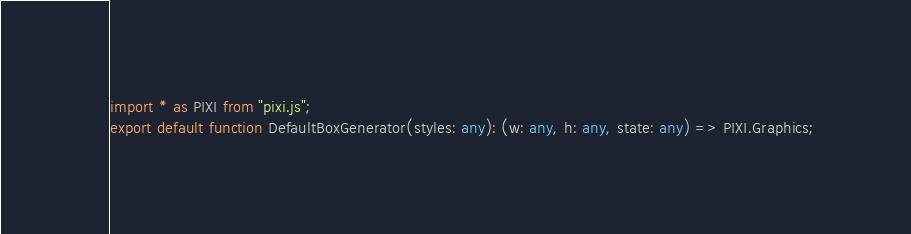Convert code to text. <code><loc_0><loc_0><loc_500><loc_500><_TypeScript_>import * as PIXI from "pixi.js";
export default function DefaultBoxGenerator(styles: any): (w: any, h: any, state: any) => PIXI.Graphics;
</code> 